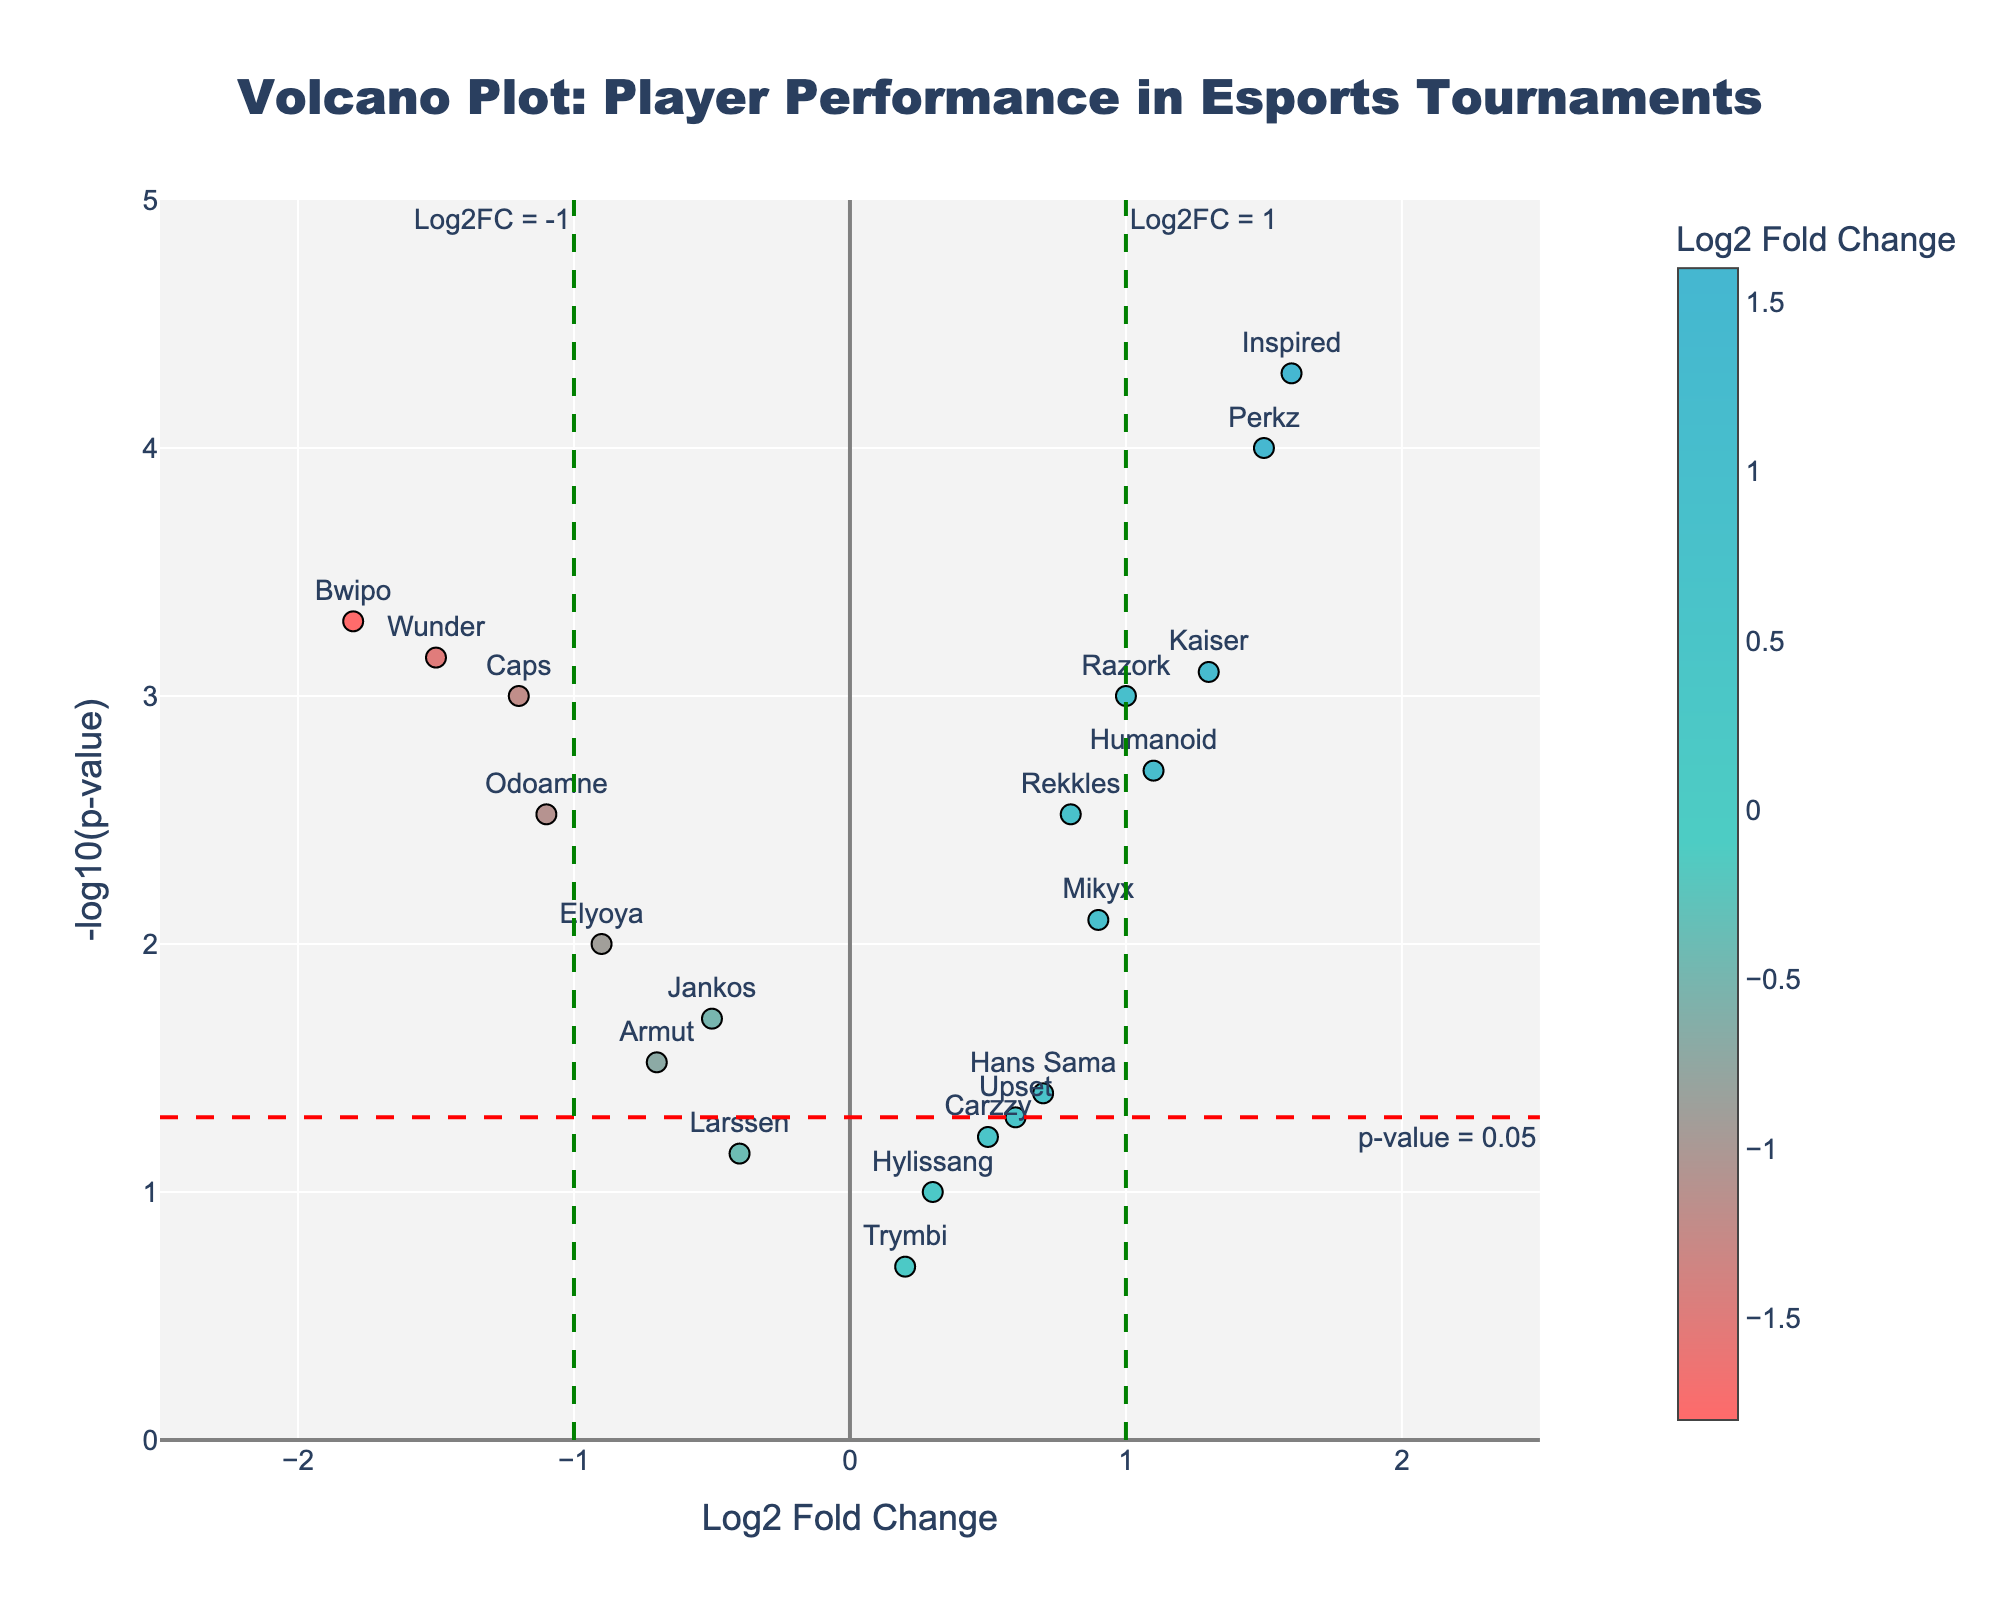What's the title of the plot? The title is usually found at the top of the plot and is intended to describe the primary focus of the visualized data.
Answer: Volcano Plot: Player Performance in Esports Tournaments What does the x-axis represent? The x-axis represents the "Log2 Fold Change", which indicates the change in performance metrics of players on a logarithmic scale.
Answer: Log2 Fold Change How many players have a positive Log2 Fold Change greater than 1? Look for data points on the plot with an x-axis value greater than 1 and count them. There are three such players: Perkz, Kaiser, and Inspired.
Answer: 3 Which player has the highest -log10(p-value) and what is that value? Identify the data point that is located the highest on the y-axis. That player is Inspired with a -log10(p-value) value close to 4.3.
Answer: Inspired, 4.3 What is the p-value threshold line in the plot? The horizontal red dashed line represents the p-value threshold, often set at 0.05. The corresponding -log10(p-value) value is -log10(0.05).
Answer: 1.3 Which players fall within both Log2 Fold Change thresholds (-1 and 1) and below the p-value threshold? Identify the data points between -1 and 1 on the x-axis and below 1.3 on the y-axis. Only Hylissang, Larssen, Upset, Carzzy and Trymbi match this criteria.
Answer: Hylissang, Larssen, Upset, Carzzy, Trymbi Who has the largest negative Log2 Fold Change and what is the value? Check the data point furthest to the left on the x-axis. Bwipo has the largest negative Log2 Fold Change at -1.8.
Answer: Bwipo, -1.8 Which players have significant performance changes, indicated by both a Log2 Fold Change greater than 1 or less than -1 and a p-value below 0.05? Find the data points with x-axis values greater than 1 or less than -1, and y-axis values above 1.3. These players are Caps, Bwipo, Perkz, Humanoid, Kaiser, Wunder, and Inspired.
Answer: Caps, Bwipo, Perkz, Humanoid, Kaiser, Wunder, Inspired What colors are used to represent Log2 Fold Changes? The plot uses a gradient color scale, starting from red for negative values, transitioning through light blue, and ending with dark blue for positive values.
Answer: Red to dark blue gradient How many players have a -log10(p-value) above 2? Count the data points with y-axis values greater than 2. These players are Caps, Bwipo, Perkz, Humanoid, Kaiser, Wunder, Mikyx, and Inspired.
Answer: 8 